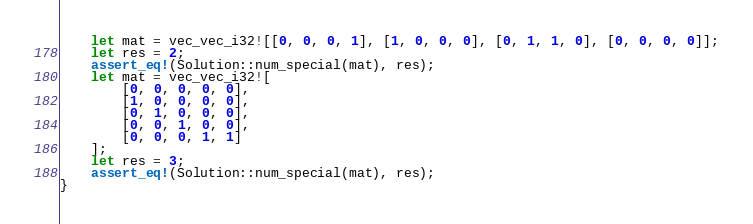<code> <loc_0><loc_0><loc_500><loc_500><_Rust_>    let mat = vec_vec_i32![[0, 0, 0, 1], [1, 0, 0, 0], [0, 1, 1, 0], [0, 0, 0, 0]];
    let res = 2;
    assert_eq!(Solution::num_special(mat), res);
    let mat = vec_vec_i32![
        [0, 0, 0, 0, 0],
        [1, 0, 0, 0, 0],
        [0, 1, 0, 0, 0],
        [0, 0, 1, 0, 0],
        [0, 0, 0, 1, 1]
    ];
    let res = 3;
    assert_eq!(Solution::num_special(mat), res);
}
</code> 